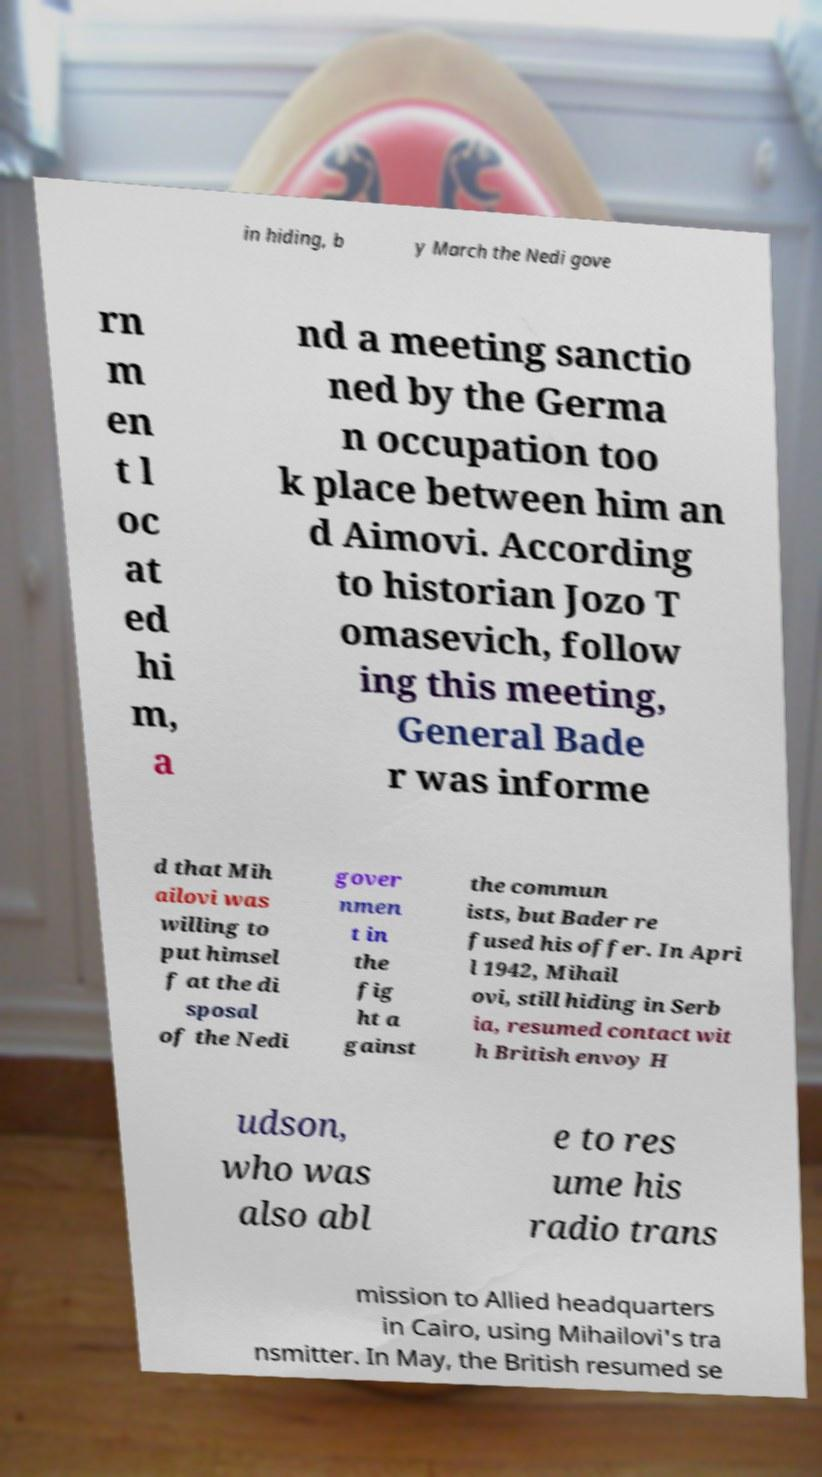Please read and relay the text visible in this image. What does it say? in hiding, b y March the Nedi gove rn m en t l oc at ed hi m, a nd a meeting sanctio ned by the Germa n occupation too k place between him an d Aimovi. According to historian Jozo T omasevich, follow ing this meeting, General Bade r was informe d that Mih ailovi was willing to put himsel f at the di sposal of the Nedi gover nmen t in the fig ht a gainst the commun ists, but Bader re fused his offer. In Apri l 1942, Mihail ovi, still hiding in Serb ia, resumed contact wit h British envoy H udson, who was also abl e to res ume his radio trans mission to Allied headquarters in Cairo, using Mihailovi's tra nsmitter. In May, the British resumed se 